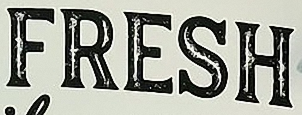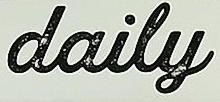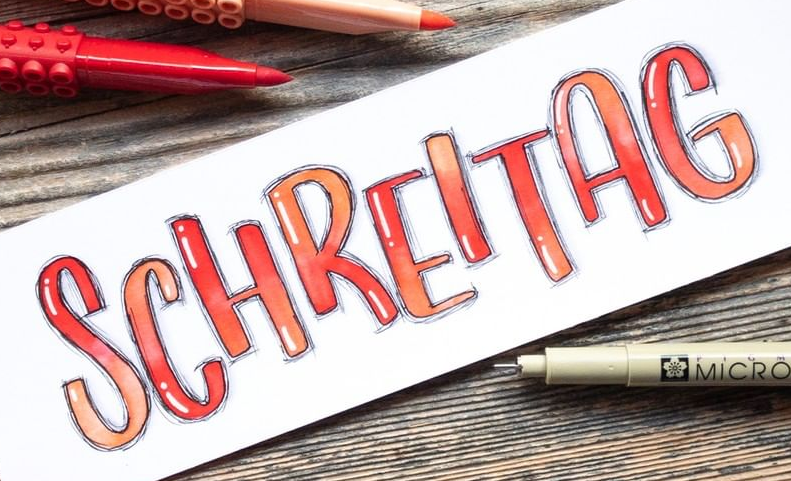What words can you see in these images in sequence, separated by a semicolon? FRESH; daily; SCHREITAG 